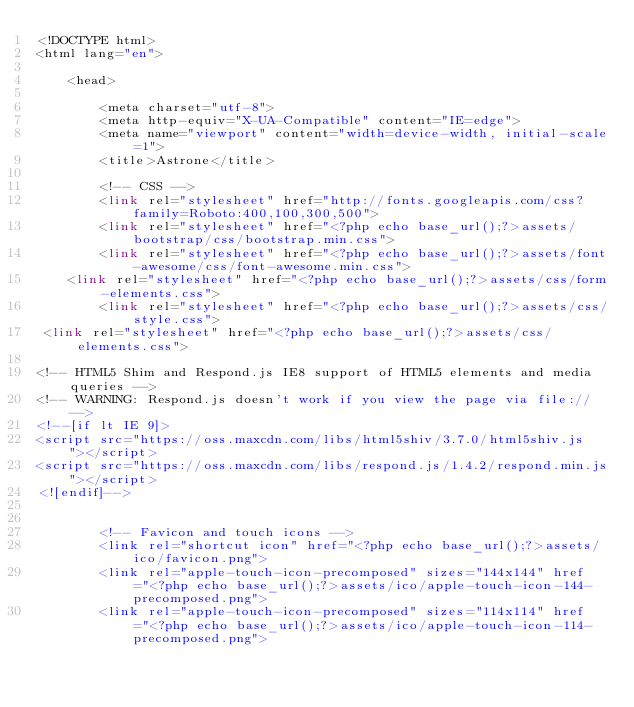Convert code to text. <code><loc_0><loc_0><loc_500><loc_500><_PHP_><!DOCTYPE html>
<html lang="en">

    <head>

        <meta charset="utf-8">
        <meta http-equiv="X-UA-Compatible" content="IE=edge">
        <meta name="viewport" content="width=device-width, initial-scale=1">
        <title>Astrone</title>

        <!-- CSS -->
        <link rel="stylesheet" href="http://fonts.googleapis.com/css?family=Roboto:400,100,300,500">
        <link rel="stylesheet" href="<?php echo base_url();?>assets/bootstrap/css/bootstrap.min.css">
        <link rel="stylesheet" href="<?php echo base_url();?>assets/font-awesome/css/font-awesome.min.css">
		<link rel="stylesheet" href="<?php echo base_url();?>assets/css/form-elements.css">
        <link rel="stylesheet" href="<?php echo base_url();?>assets/css/style.css">
 <link rel="stylesheet" href="<?php echo base_url();?>assets/css/elements.css">

<!-- HTML5 Shim and Respond.js IE8 support of HTML5 elements and media queries -->
<!-- WARNING: Respond.js doesn't work if you view the page via file:// -->
<!--[if lt IE 9]>
<script src="https://oss.maxcdn.com/libs/html5shiv/3.7.0/html5shiv.js"></script>
<script src="https://oss.maxcdn.com/libs/respond.js/1.4.2/respond.min.js"></script>
<![endif]-->


        <!-- Favicon and touch icons -->
        <link rel="shortcut icon" href="<?php echo base_url();?>assets/ico/favicon.png">
        <link rel="apple-touch-icon-precomposed" sizes="144x144" href="<?php echo base_url();?>assets/ico/apple-touch-icon-144-precomposed.png">
        <link rel="apple-touch-icon-precomposed" sizes="114x114" href="<?php echo base_url();?>assets/ico/apple-touch-icon-114-precomposed.png"></code> 